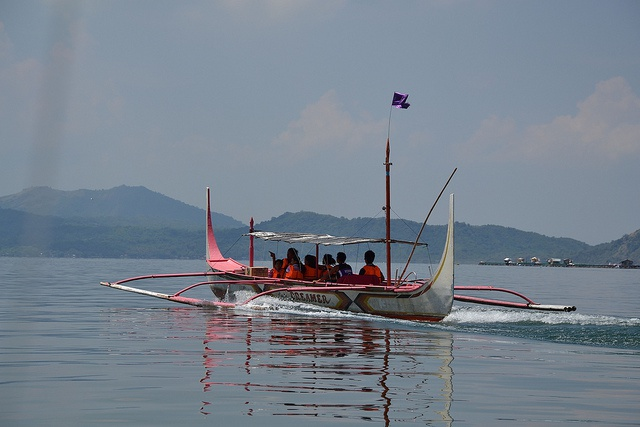Describe the objects in this image and their specific colors. I can see boat in gray, black, and darkgray tones, people in gray, black, and maroon tones, people in gray, black, maroon, and red tones, people in gray, black, maroon, and darkblue tones, and people in gray, black, maroon, and blue tones in this image. 